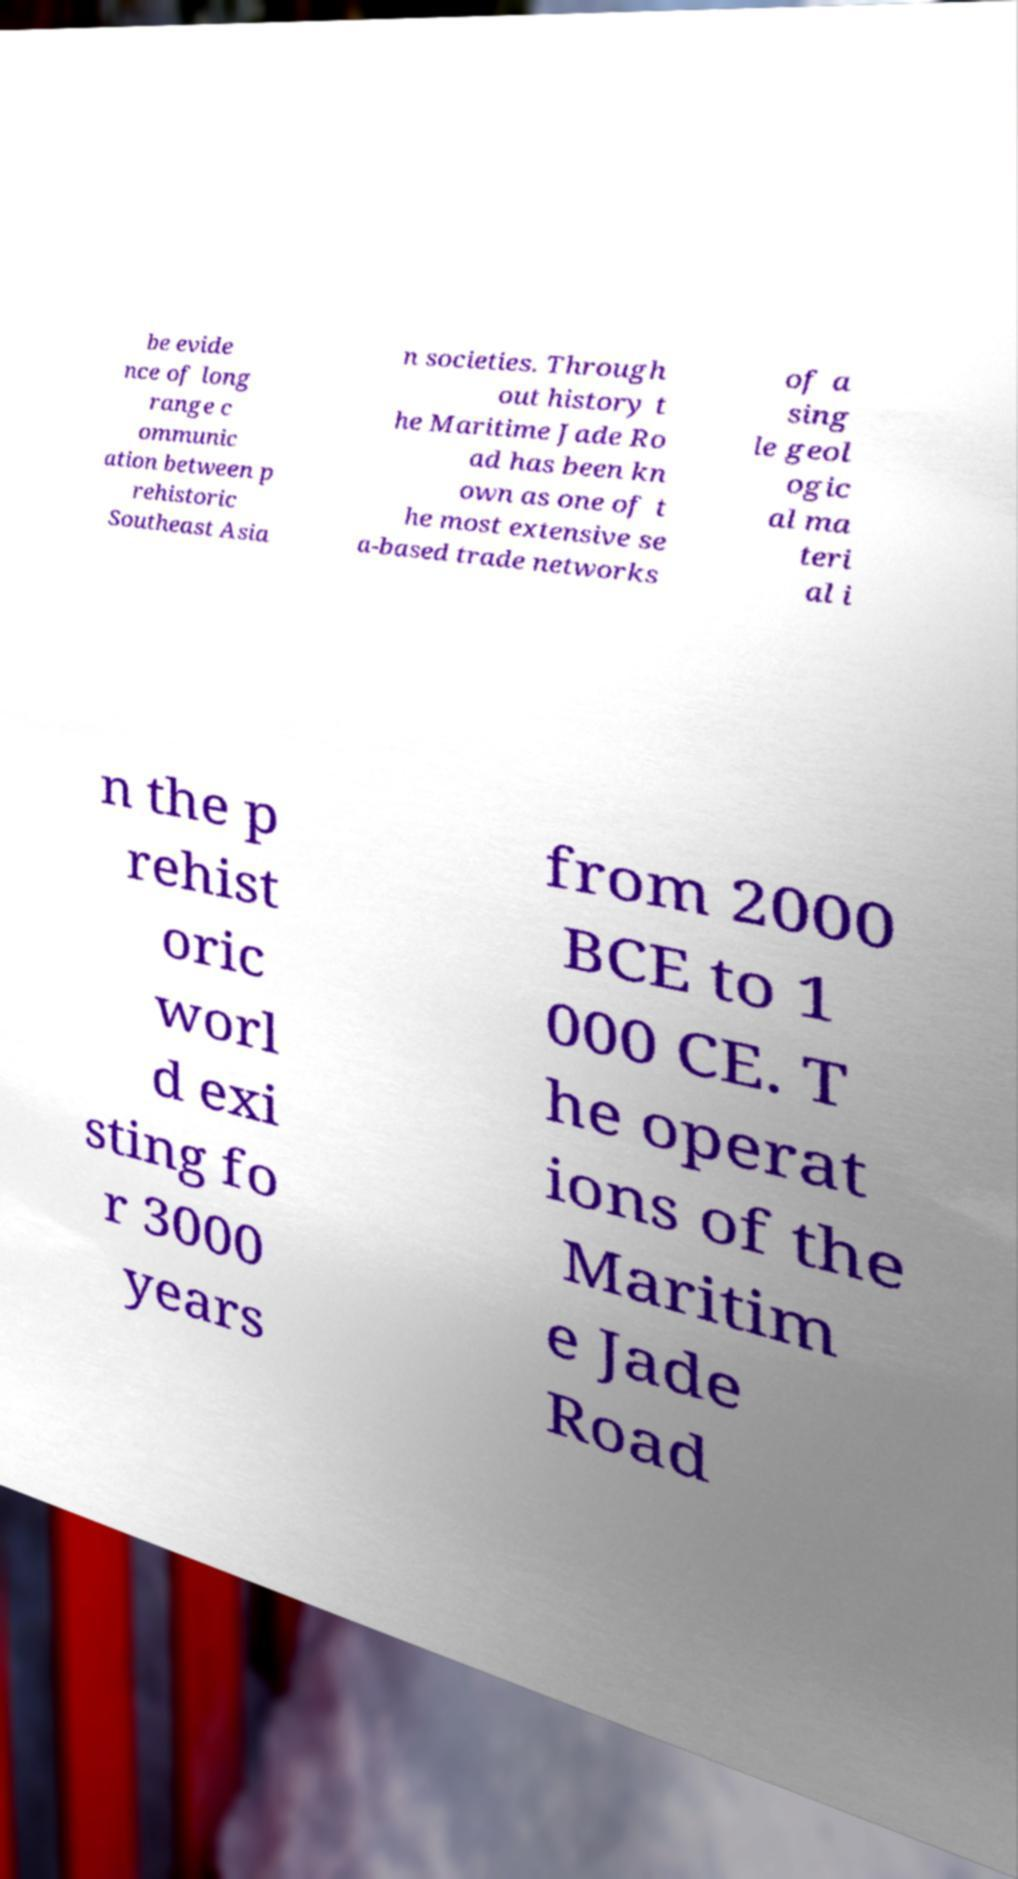There's text embedded in this image that I need extracted. Can you transcribe it verbatim? be evide nce of long range c ommunic ation between p rehistoric Southeast Asia n societies. Through out history t he Maritime Jade Ro ad has been kn own as one of t he most extensive se a-based trade networks of a sing le geol ogic al ma teri al i n the p rehist oric worl d exi sting fo r 3000 years from 2000 BCE to 1 000 CE. T he operat ions of the Maritim e Jade Road 